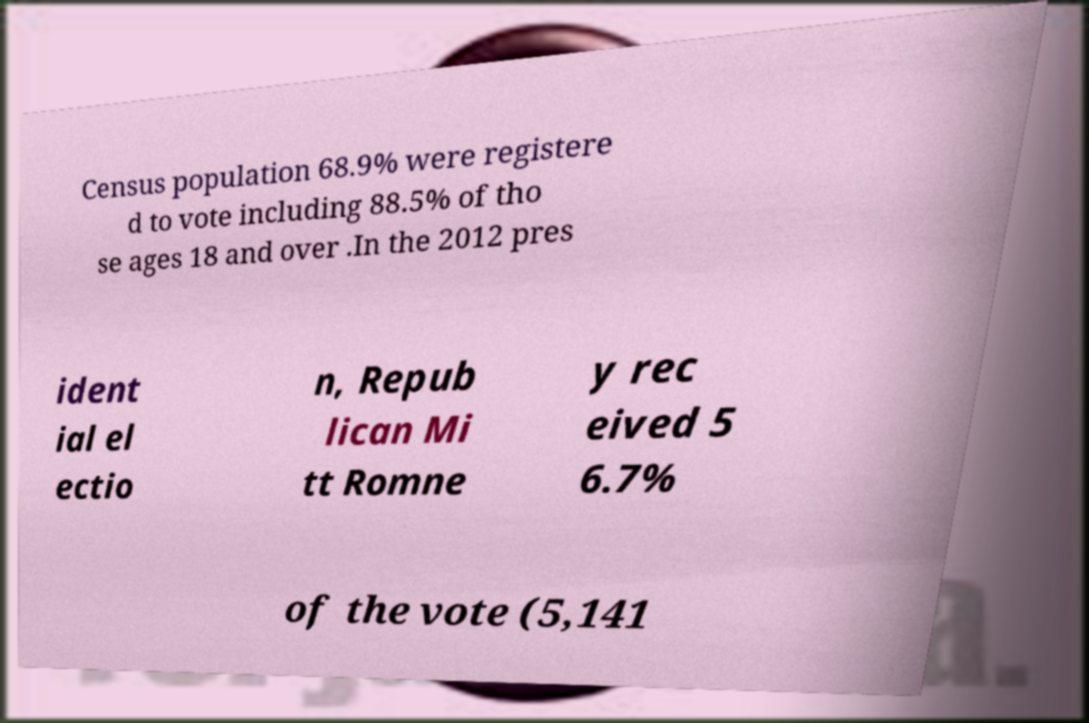I need the written content from this picture converted into text. Can you do that? Census population 68.9% were registere d to vote including 88.5% of tho se ages 18 and over .In the 2012 pres ident ial el ectio n, Repub lican Mi tt Romne y rec eived 5 6.7% of the vote (5,141 